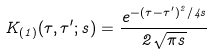Convert formula to latex. <formula><loc_0><loc_0><loc_500><loc_500>K _ { ( 1 ) } ( \tau , \tau ^ { \prime } ; s ) = \frac { e ^ { - ( \tau - \tau ^ { \prime } ) ^ { 2 } / 4 s } } { 2 \sqrt { \pi s } }</formula> 